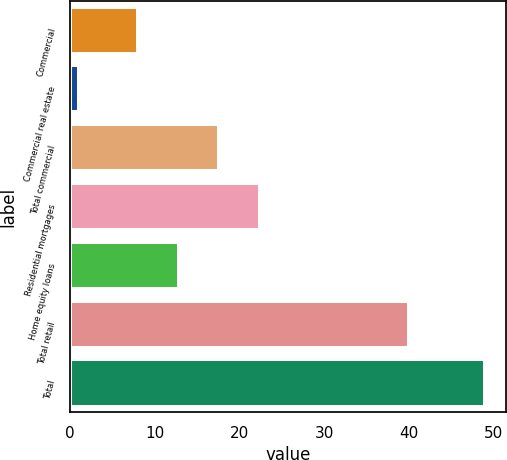<chart> <loc_0><loc_0><loc_500><loc_500><bar_chart><fcel>Commercial<fcel>Commercial real estate<fcel>Total commercial<fcel>Residential mortgages<fcel>Home equity loans<fcel>Total retail<fcel>Total<nl><fcel>8<fcel>1<fcel>17.6<fcel>22.4<fcel>12.8<fcel>40<fcel>49<nl></chart> 